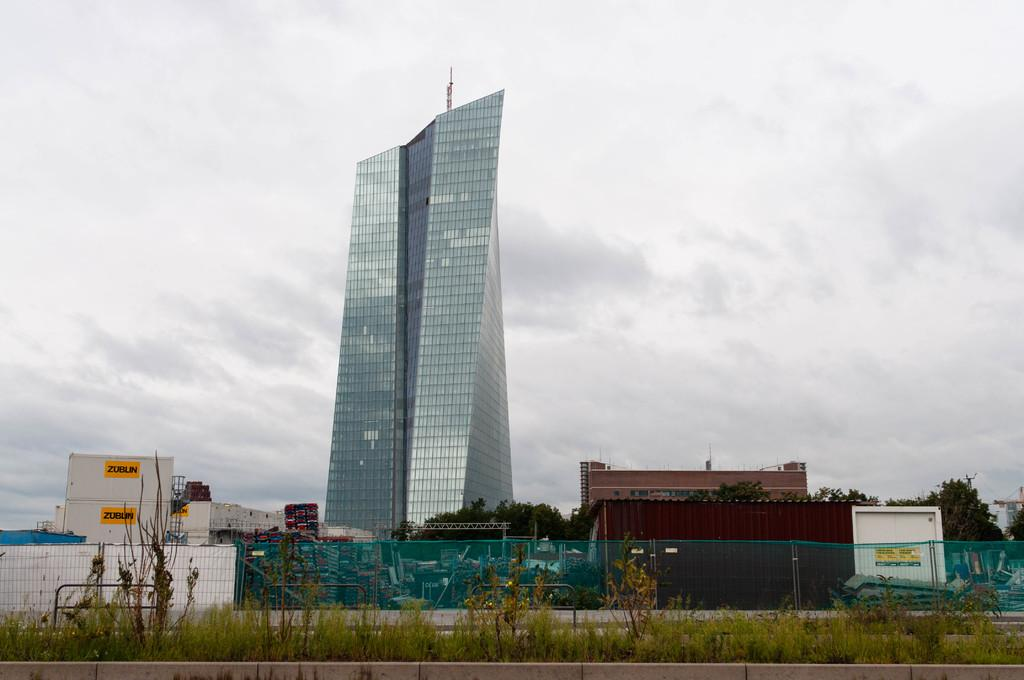What is located at the bottom of the image? A: There are plants at the bottom of the image. What can be seen in the background of the image? In the background, there is a fence, buildings, trees, and posters. What is visible in the sky in the image? There are clouds visible in the sky. How many loaves of bread can be seen on the trail in the image? There is no trail or loaves of bread present in the image. What type of cent is depicted on the posters in the background? There is no cent or any indication of currency on the posters in the background. 